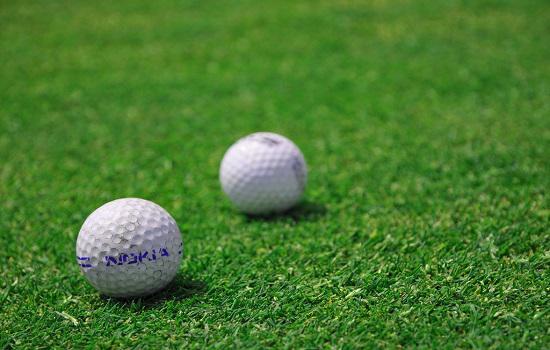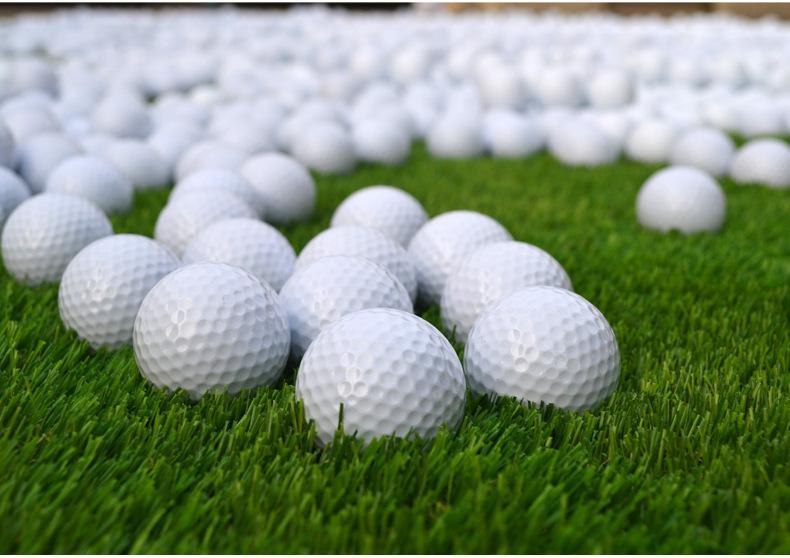The first image is the image on the left, the second image is the image on the right. Examine the images to the left and right. Is the description "One image contains a mass of all-white balls on green turf, most with no space between them." accurate? Answer yes or no. Yes. The first image is the image on the left, the second image is the image on the right. Given the left and right images, does the statement "There are exactly two golf balls in one of the images." hold true? Answer yes or no. Yes. 